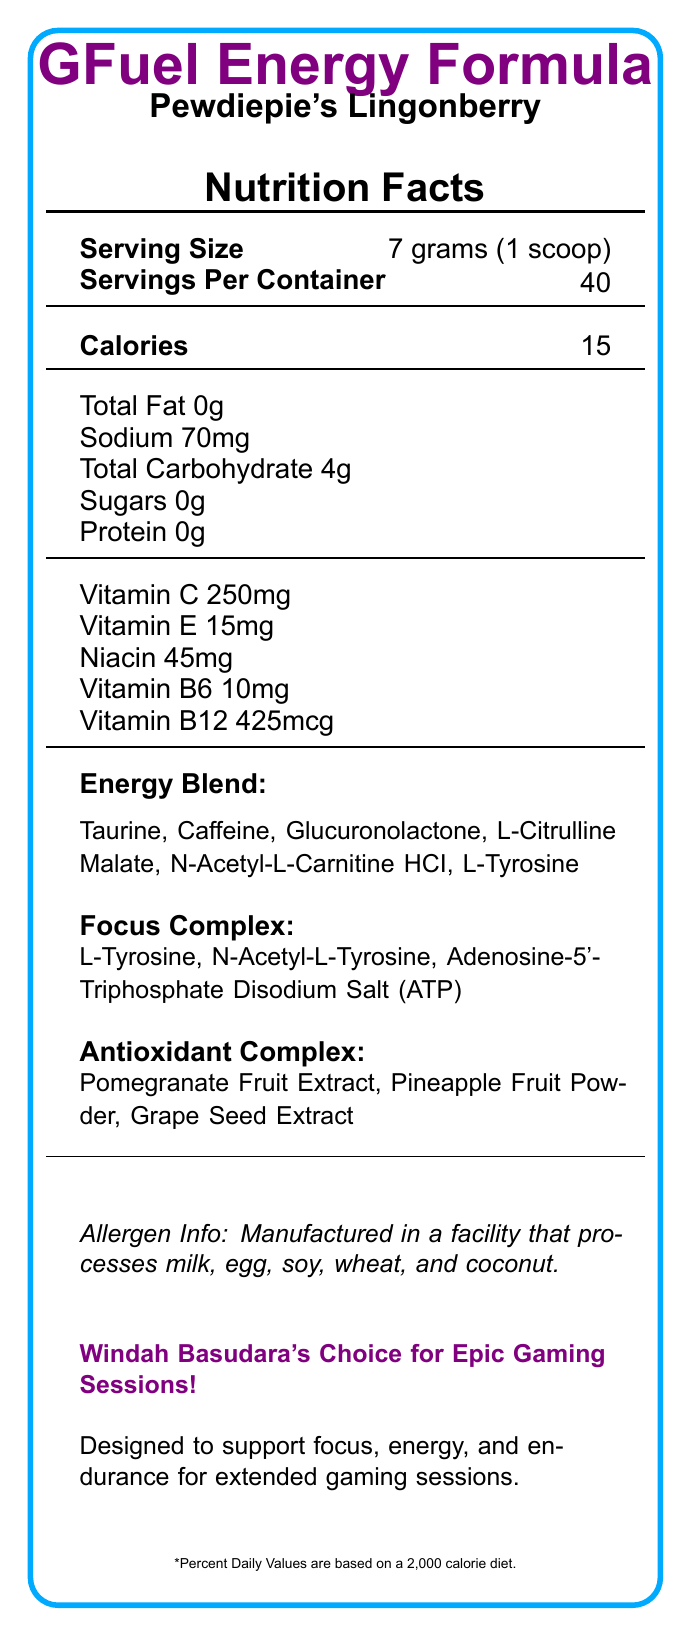What is the serving size for GFuel Energy Formula? The document specifies that the serving size is 7 grams, equivalent to 1 scoop.
Answer: 7 grams (1 scoop) How many servings are there per container of GFuel Energy Formula? According to the document, there are 40 servings per container.
Answer: 40 What is the calorie count per serving of GFuel? The document states that there are 15 calories in each serving.
Answer: 15 How much sodium does one serving of GFuel Energy Formula contain? The document mentions that the sodium content per serving is 70mg.
Answer: 70mg List three ingredients in the Energy Blend of GFuel Energy Formula. The document lists the Energy Blend components as Taurine, Caffeine, Glucuronolactone, L-Citrulline Malate, N-Acetyl-L-Carnitine HCI, and L-Tyrosine.
Answer: Taurine, Caffeine, Glucuronolactone What is the flavor of this GFuel Energy Formula? A. Blue Raspberry B. Pewdiepie's Lingonberry C. Tropical Rain The document informs us that the flavor is Pewdiepie's Lingonberry.
Answer: B. Pewdiepie's Lingonberry Which vitamin is present in the highest amount in GFuel Energy Formula? A. Vitamin C B. Vitamin E C. Vitamin B6 D. Vitamin B12 The document states that 250mg of Vitamin C is present, which is higher than the amounts of other vitamins listed.
Answer: A. Vitamin C Does GFuel Energy Formula contain any sugars? The document specifies that the product contains 0g of sugars.
Answer: No Is GFuel Energy Formula free of proteins? The product's protein content is listed as 0g in the document.
Answer: Yes Summarize the nutrition and purpose of GFuel Energy Formula. The document details that GFuel has a serving size of 7 grams, 15 calories per serving, and key ingredients such as vitamins, taurine, caffeine, and specific blends for energy and focus. It is marketed to support gaming performance.
Answer: GFuel Energy Formula is a low-calorie energy drink designed to support focus, energy, and endurance for extended gaming sessions. It contains no fat, sugars, or protein but includes essential vitamins, caffeine, and various blends to enhance performance. Where is GFuel Energy Formula manufactured? The document does not provide information about the manufacturing location of GFuel Energy Formula.
Answer: Not enough information What allergens are processed in the facility that manufactures GFuel Energy Formula? The document mentions that GFuel Energy Formula is manufactured in a facility processing milk, egg, soy, wheat, and coconut.
Answer: Milk, egg, soy, wheat, and coconut How much caffeine is in one serving of GFuel Energy Formula? The document specifies that each serving contains 140mg of caffeine.
Answer: 140mg What is the main purpose of the Focus Complex in GFuel Energy Formula? The document indicates that the Focus Complex includes ingredients like L-Tyrosine and ATP, aimed at enhancing focus for gaming.
Answer: To support focus during extended gaming sessions. Identify three components of the Antioxidant Complex in GFuel Energy Formula. The document lists these three items under the Antioxidant Complex section.
Answer: Pomegranate Fruit Extract, Pineapple Fruit Powder, Grape Seed Extract 